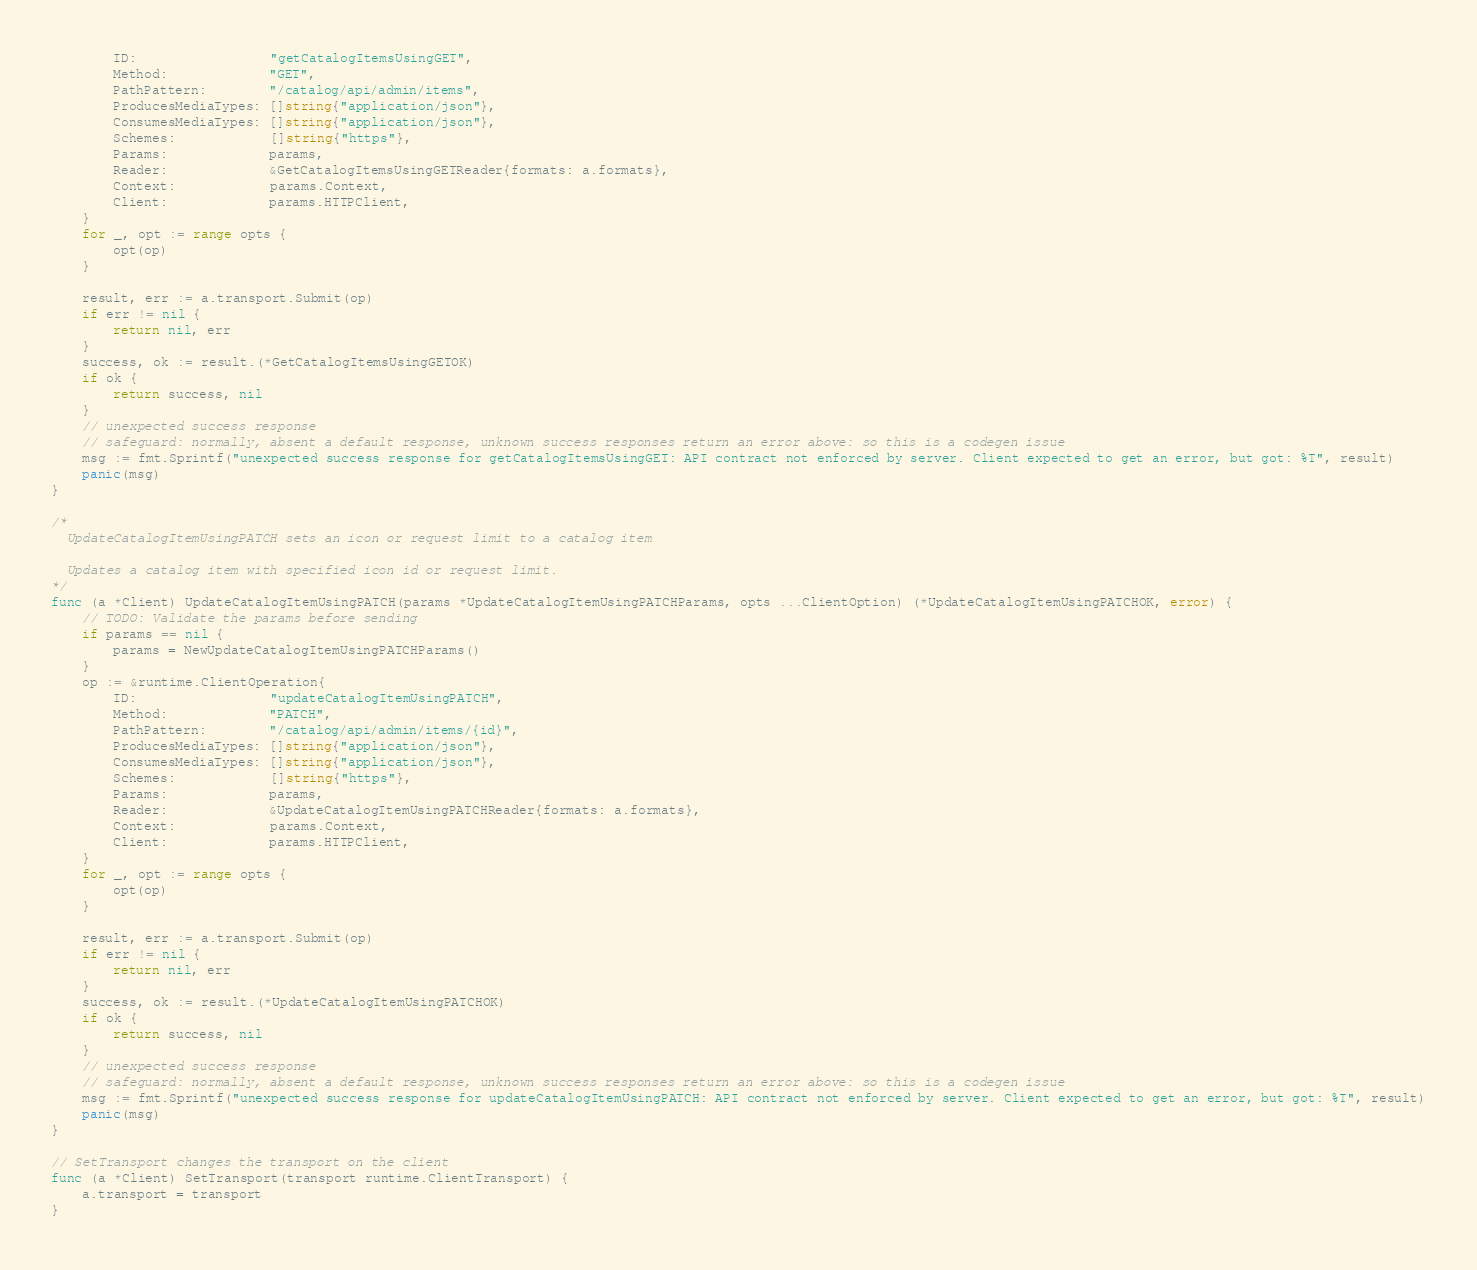<code> <loc_0><loc_0><loc_500><loc_500><_Go_>		ID:                 "getCatalogItemsUsingGET",
		Method:             "GET",
		PathPattern:        "/catalog/api/admin/items",
		ProducesMediaTypes: []string{"application/json"},
		ConsumesMediaTypes: []string{"application/json"},
		Schemes:            []string{"https"},
		Params:             params,
		Reader:             &GetCatalogItemsUsingGETReader{formats: a.formats},
		Context:            params.Context,
		Client:             params.HTTPClient,
	}
	for _, opt := range opts {
		opt(op)
	}

	result, err := a.transport.Submit(op)
	if err != nil {
		return nil, err
	}
	success, ok := result.(*GetCatalogItemsUsingGETOK)
	if ok {
		return success, nil
	}
	// unexpected success response
	// safeguard: normally, absent a default response, unknown success responses return an error above: so this is a codegen issue
	msg := fmt.Sprintf("unexpected success response for getCatalogItemsUsingGET: API contract not enforced by server. Client expected to get an error, but got: %T", result)
	panic(msg)
}

/*
  UpdateCatalogItemUsingPATCH sets an icon or request limit to a catalog item

  Updates a catalog item with specified icon id or request limit.
*/
func (a *Client) UpdateCatalogItemUsingPATCH(params *UpdateCatalogItemUsingPATCHParams, opts ...ClientOption) (*UpdateCatalogItemUsingPATCHOK, error) {
	// TODO: Validate the params before sending
	if params == nil {
		params = NewUpdateCatalogItemUsingPATCHParams()
	}
	op := &runtime.ClientOperation{
		ID:                 "updateCatalogItemUsingPATCH",
		Method:             "PATCH",
		PathPattern:        "/catalog/api/admin/items/{id}",
		ProducesMediaTypes: []string{"application/json"},
		ConsumesMediaTypes: []string{"application/json"},
		Schemes:            []string{"https"},
		Params:             params,
		Reader:             &UpdateCatalogItemUsingPATCHReader{formats: a.formats},
		Context:            params.Context,
		Client:             params.HTTPClient,
	}
	for _, opt := range opts {
		opt(op)
	}

	result, err := a.transport.Submit(op)
	if err != nil {
		return nil, err
	}
	success, ok := result.(*UpdateCatalogItemUsingPATCHOK)
	if ok {
		return success, nil
	}
	// unexpected success response
	// safeguard: normally, absent a default response, unknown success responses return an error above: so this is a codegen issue
	msg := fmt.Sprintf("unexpected success response for updateCatalogItemUsingPATCH: API contract not enforced by server. Client expected to get an error, but got: %T", result)
	panic(msg)
}

// SetTransport changes the transport on the client
func (a *Client) SetTransport(transport runtime.ClientTransport) {
	a.transport = transport
}
</code> 